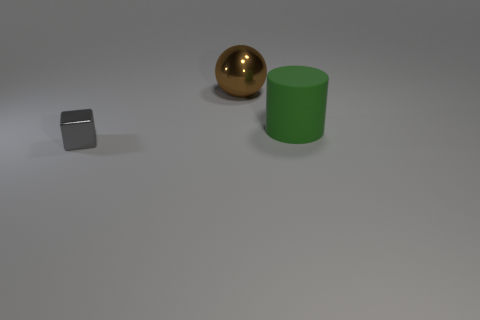Add 2 brown metallic things. How many objects exist? 5 Subtract all balls. How many objects are left? 2 Subtract 1 cylinders. How many cylinders are left? 0 Subtract all gray balls. Subtract all red cubes. How many balls are left? 1 Subtract all purple metal cubes. Subtract all big things. How many objects are left? 1 Add 1 gray blocks. How many gray blocks are left? 2 Add 2 large green matte objects. How many large green matte objects exist? 3 Subtract 1 brown spheres. How many objects are left? 2 